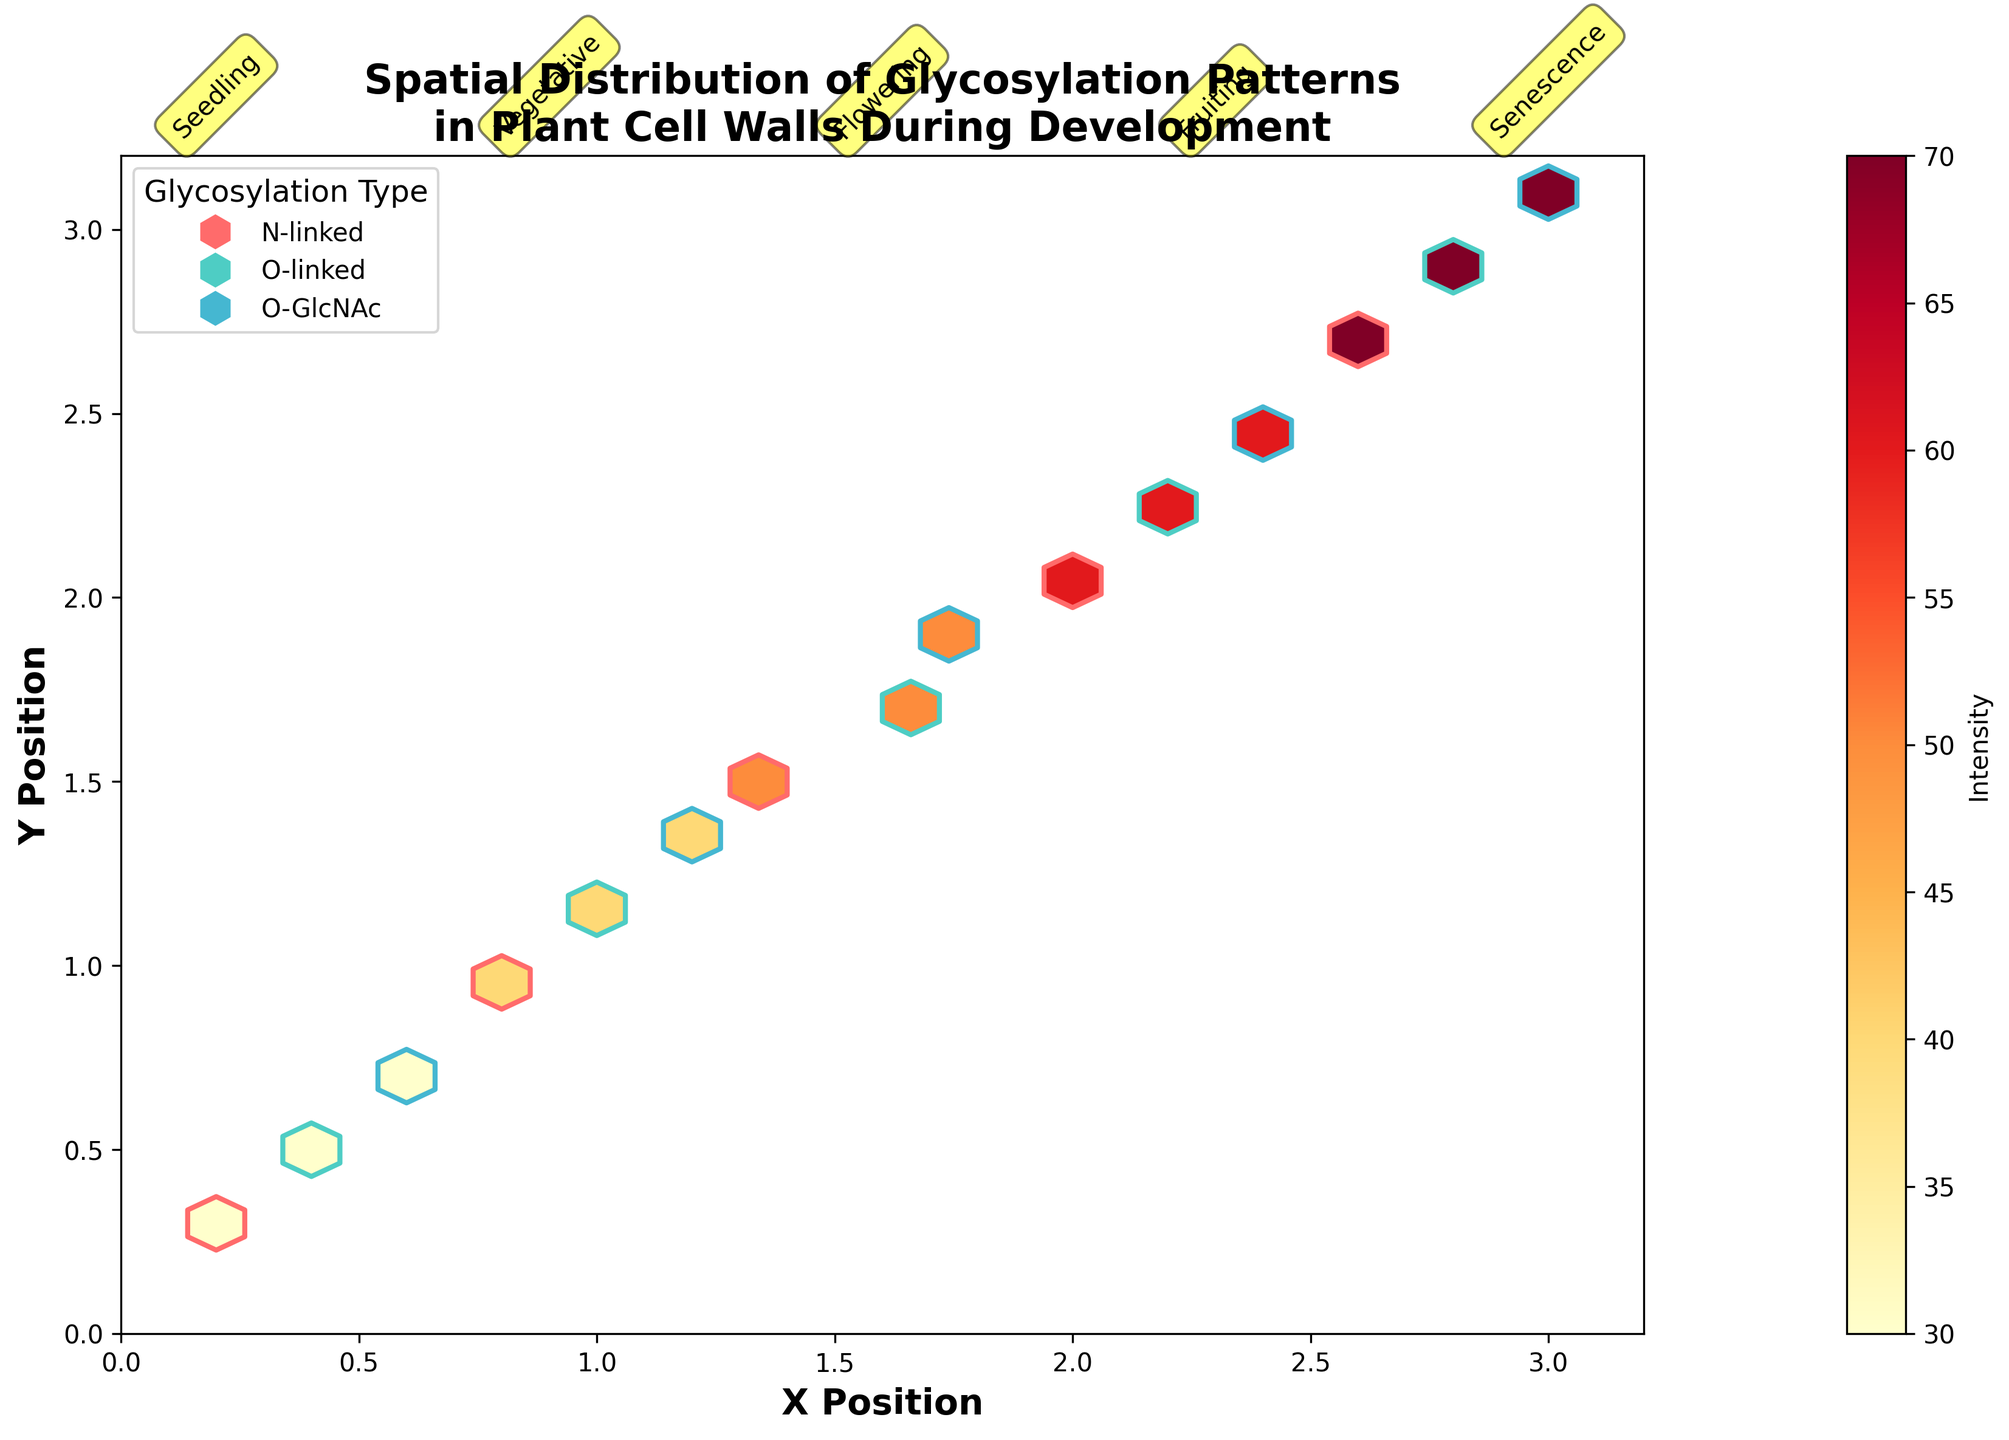What is the title of the hexbin plot? The title of the hexbin plot is located at the top of the plot. It reads "Spatial Distribution of Glycosylation Patterns in Plant Cell Walls During Development."
Answer: Spatial Distribution of Glycosylation Patterns in Plant Cell Walls During Development What do the X and Y axes in the hexbin plot represent? The labels on the X and Y axes provide information about what they represent. The X axis is labeled "X Position" and the Y axis is labeled "Y Position."
Answer: X Position and Y Position How many developmental stages are annotated in the hexbin plot? The annotations above the hexbin plot show the different developmental stages. By counting these annotations, we can determine the number of stages. The stages are seedling, vegetative, flowering, fruiting, and senescence, making a total of five stages.
Answer: 5 What does the color bar on the right side of the hexbin plot represent? The color bar is labeled "Intensity," and this label, along with the gradient shown, indicates that it represents the intensity of glycosylation at various points on the hexbin plot.
Answer: Intensity Which glycosylation type has the highest intensity in the senescence stage? To answer this, we look at the hexbin plot for data corresponding to the senescence stage. We then identify the hexagons with the highest intensity and check the legend to determine which glycosylation type they belong to. The O-linked glycosylation type has the highest intensity, indicated by its distinct color in the legend.
Answer: O-linked Compare the intensity of N-linked glycosylation between the vegetative and fruiting stages. Which stage has higher intensity? By examining the hexbin plot and focusing on the N-linked glycosylation color, we compare the intensities during the vegetative and fruiting stages. The fruiting stage shows higher intensity, as indicated by the darker color in the corresponding hexagons.
Answer: Fruiting What is the grid size used in the hexbin plot? The code that generates the plot specifies a gridsize of 20 for the hexbin function. This information can also be inferred by examining the density of the hexagons in the plot, although it is more code-specific information.
Answer: 20 Is there any overlap in color between the different glycosylation types in the hexbin plot? Observing the hexbin plot and the legend, we can see that each glycosylation type is represented by a unique edge color (red for N-linked, teal for O-linked, and blue for O-GlcNAc). Thus, there is no overlap in color between the different glycosylation types.
Answer: No Which glycosylation type shows the most evenly spread distribution across all stages? Analyzing the hexbin plot by looking at the spatial distribution and edge colors, we can see that the O-GlcNAc glycosylation type is the most evenly spread across all stages, as indicated by its consistent and widespread hexagons throughout the plot.
Answer: O-GlcNAc 